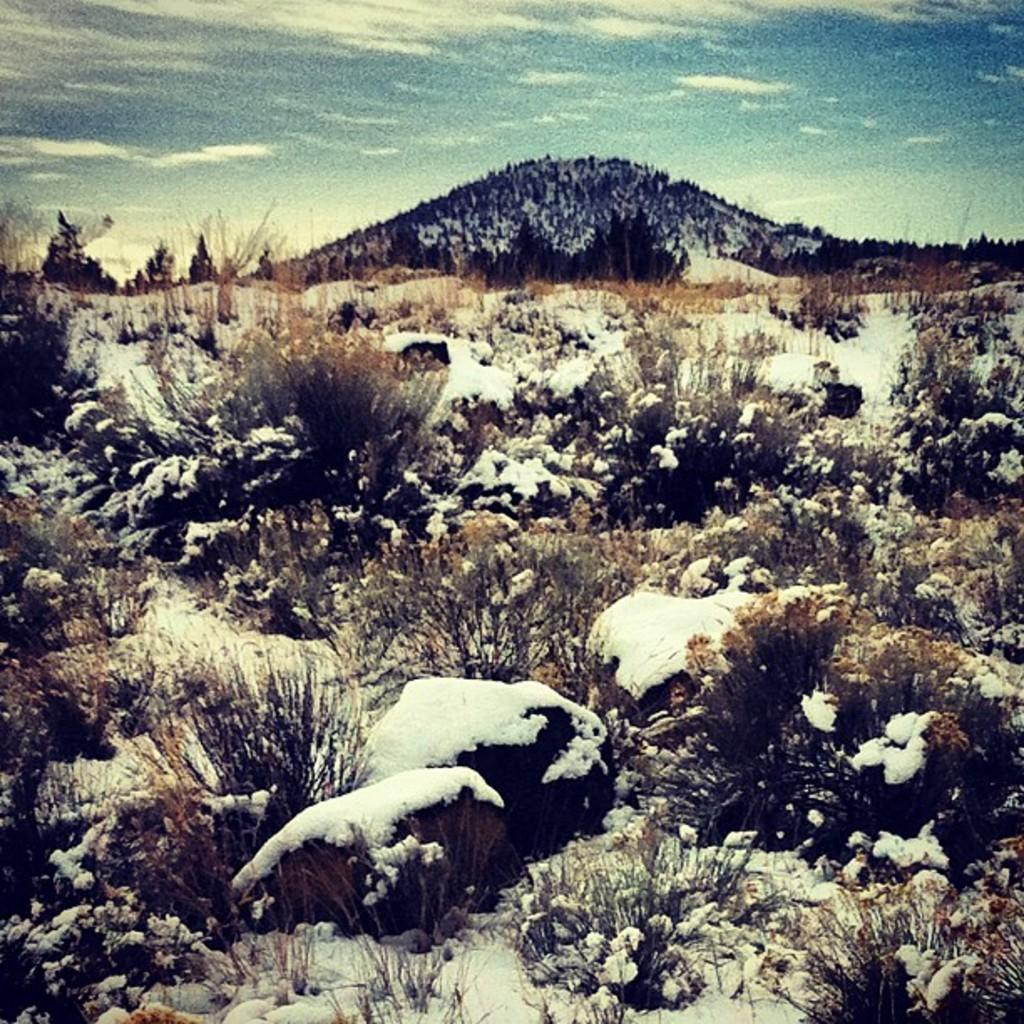What type of natural elements can be seen in the image? There are stones, grass, and snow visible in the image. What part of the natural environment is visible in the image? The sky is visible in the image. What can be seen in the sky in the image? There are clouds in the image. What type of collar can be seen on the snow in the image? There is no collar present in the image, as the snow is a natural element and not an object with a collar. 